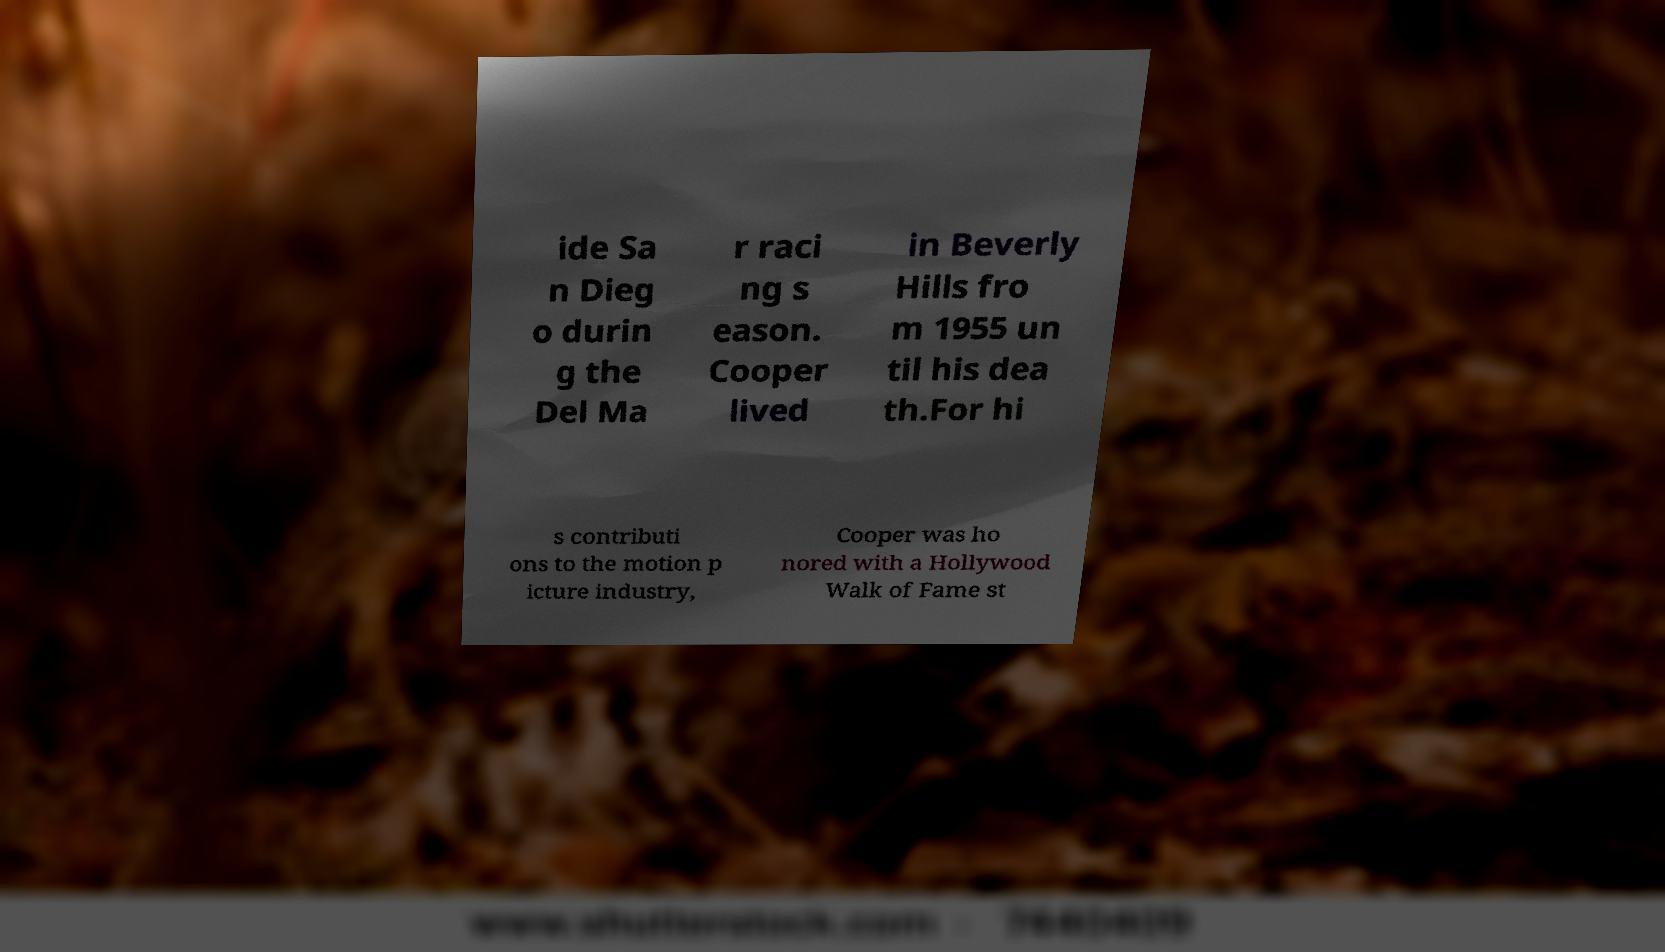Could you assist in decoding the text presented in this image and type it out clearly? ide Sa n Dieg o durin g the Del Ma r raci ng s eason. Cooper lived in Beverly Hills fro m 1955 un til his dea th.For hi s contributi ons to the motion p icture industry, Cooper was ho nored with a Hollywood Walk of Fame st 